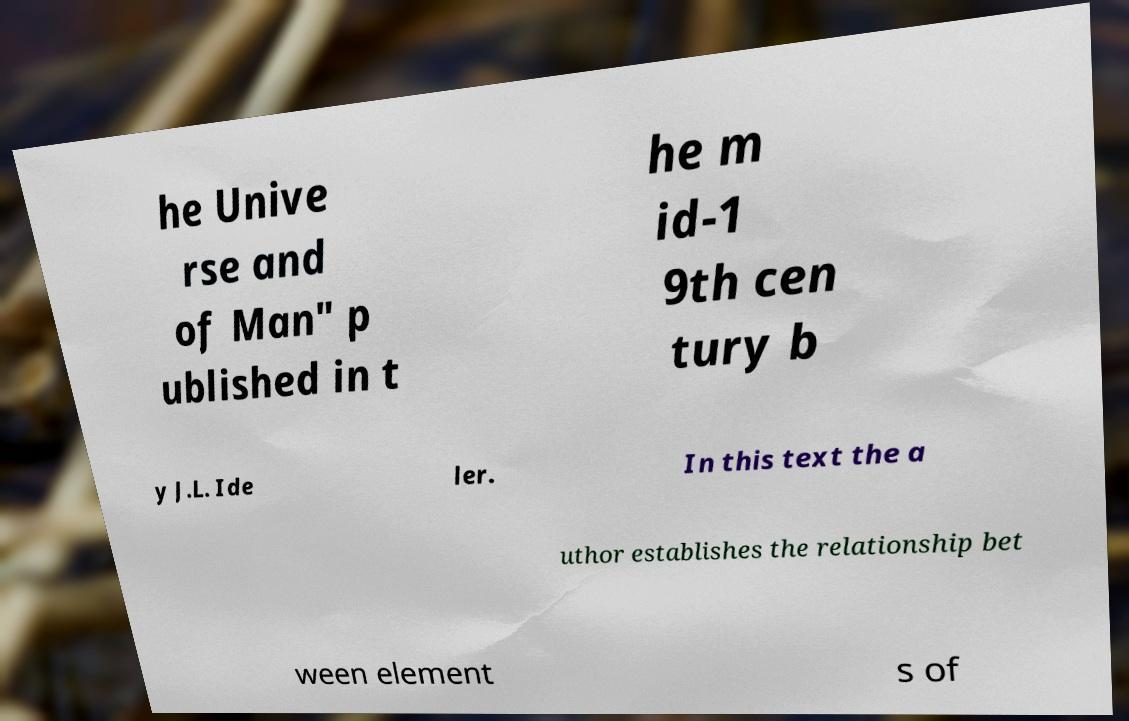What messages or text are displayed in this image? I need them in a readable, typed format. he Unive rse and of Man" p ublished in t he m id-1 9th cen tury b y J.L. Ide ler. In this text the a uthor establishes the relationship bet ween element s of 